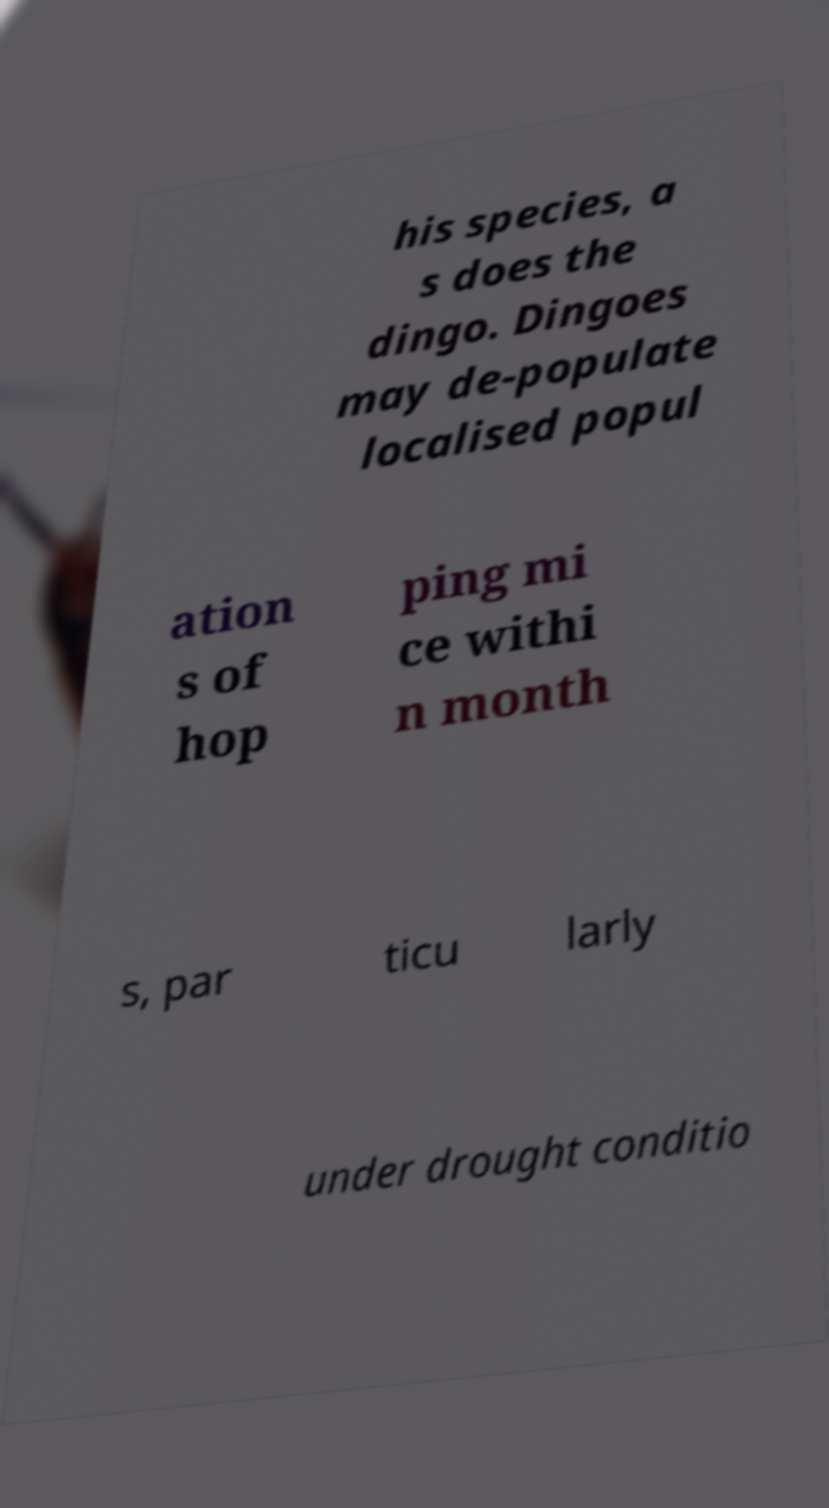There's text embedded in this image that I need extracted. Can you transcribe it verbatim? his species, a s does the dingo. Dingoes may de-populate localised popul ation s of hop ping mi ce withi n month s, par ticu larly under drought conditio 